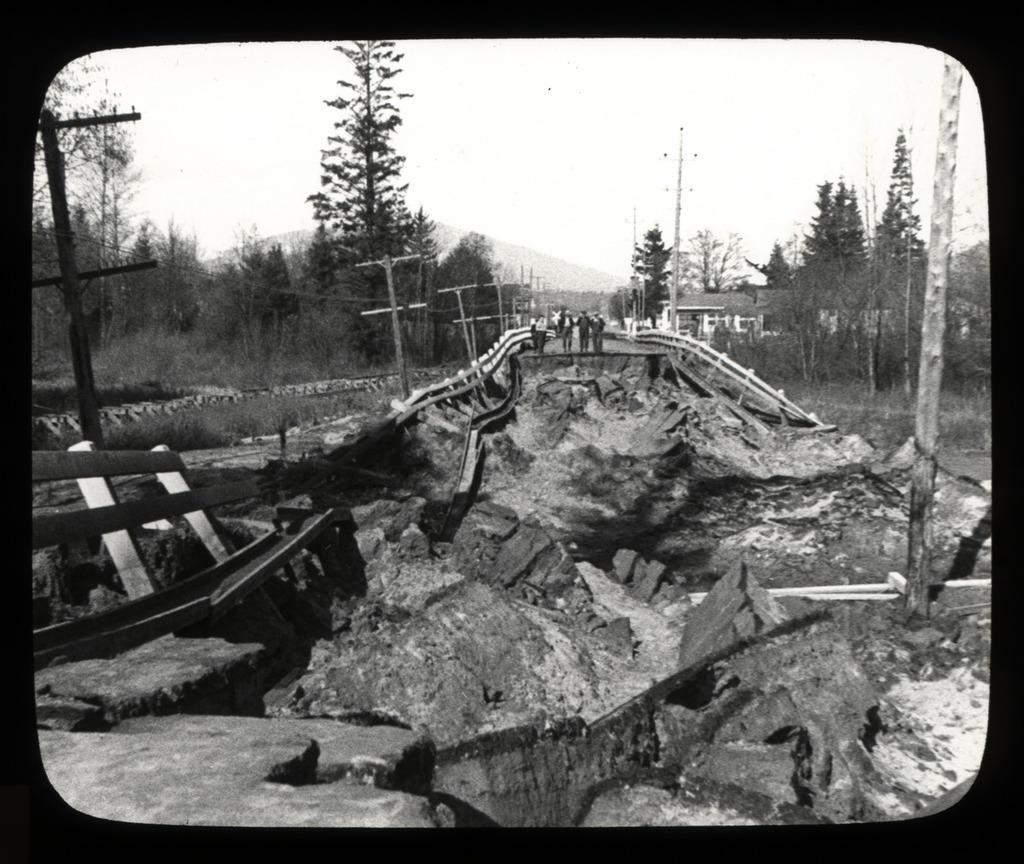In one or two sentences, can you explain what this image depicts? In this picture there is view of the damaged bridge. On the left side there is some metal fencing guards are placed on the ground. Behind there are four persons standing and looking to the bridge. In the Background there are some street poles and many trees. 